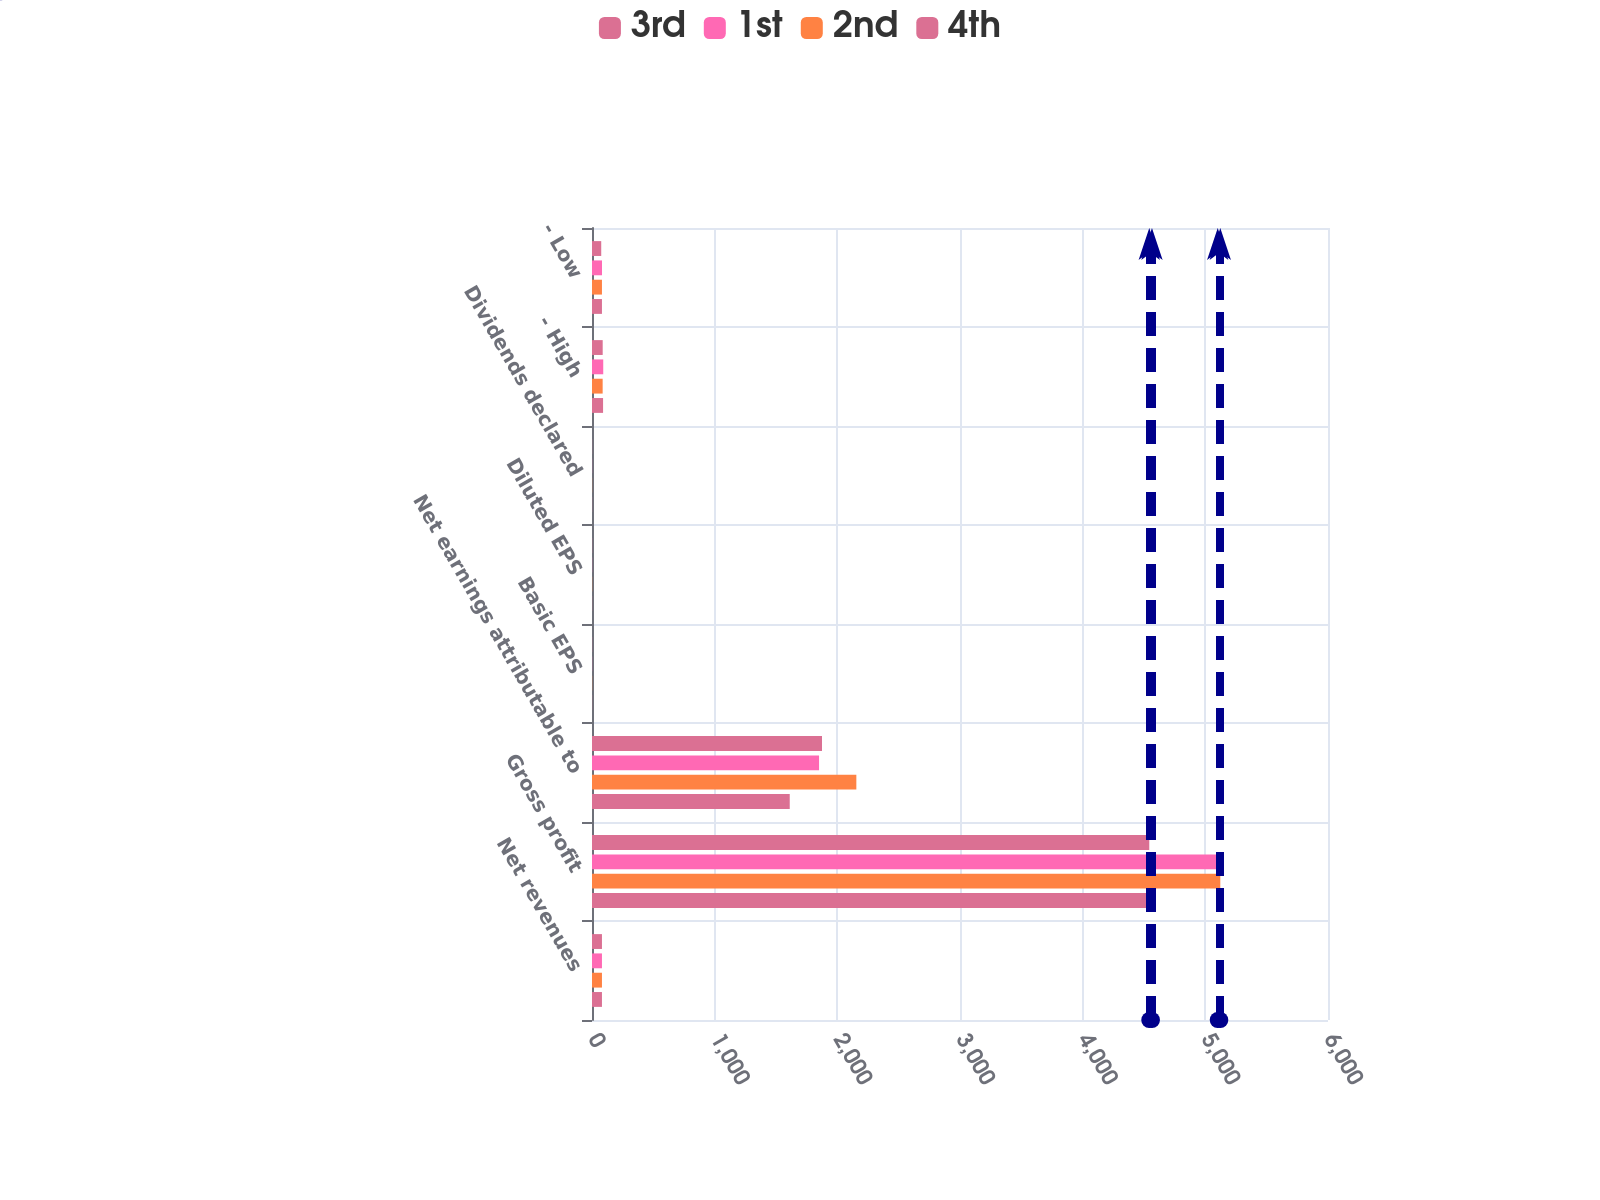<chart> <loc_0><loc_0><loc_500><loc_500><stacked_bar_chart><ecel><fcel>Net revenues<fcel>Gross profit<fcel>Net earnings attributable to<fcel>Basic EPS<fcel>Diluted EPS<fcel>Dividends declared<fcel>- High<fcel>- Low<nl><fcel>3rd<fcel>81.175<fcel>4543<fcel>1875<fcel>1.18<fcel>1.18<fcel>0.94<fcel>87.2<fcel>75.28<nl><fcel>1st<fcel>81.175<fcel>5101<fcel>1851<fcel>1.17<fcel>1.17<fcel>0.94<fcel>91.63<fcel>81.7<nl><fcel>2nd<fcel>81.175<fcel>5122<fcel>2155<fcel>1.38<fcel>1.38<fcel>1<fcel>86.85<fcel>81.19<nl><fcel>4th<fcel>81.175<fcel>4565<fcel>1612<fcel>1.03<fcel>1.03<fcel>1<fcel>90.25<fcel>81.16<nl></chart> 